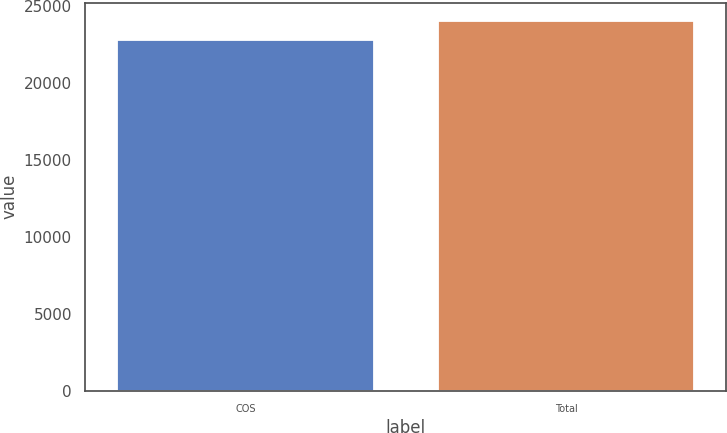Convert chart. <chart><loc_0><loc_0><loc_500><loc_500><bar_chart><fcel>COS<fcel>Total<nl><fcel>22775<fcel>24024<nl></chart> 